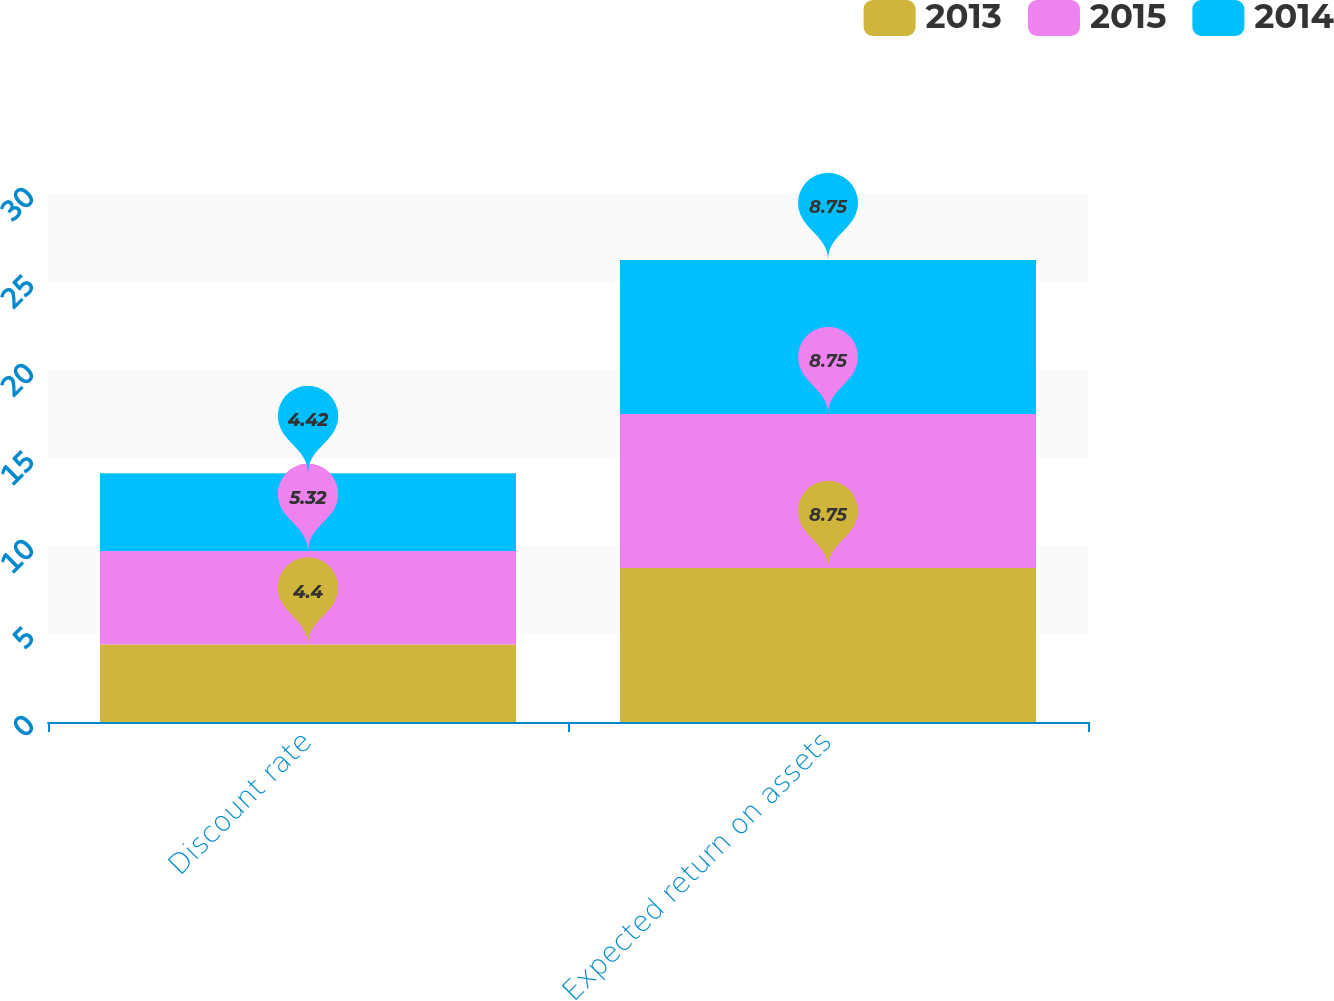Convert chart to OTSL. <chart><loc_0><loc_0><loc_500><loc_500><stacked_bar_chart><ecel><fcel>Discount rate<fcel>Expected return on assets<nl><fcel>2013<fcel>4.4<fcel>8.75<nl><fcel>2015<fcel>5.32<fcel>8.75<nl><fcel>2014<fcel>4.42<fcel>8.75<nl></chart> 